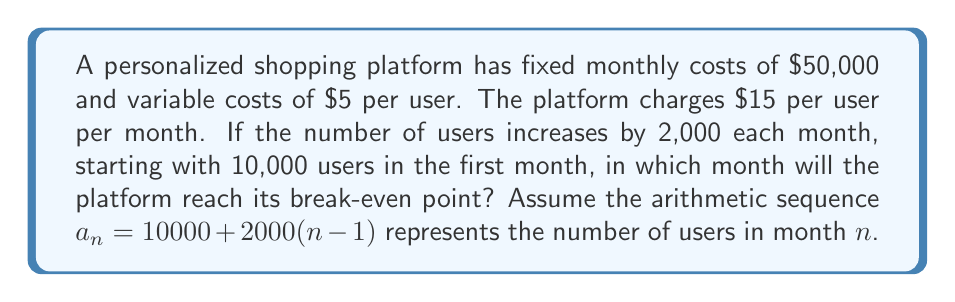Can you answer this question? Let's approach this step-by-step:

1) First, we need to set up the revenue and cost functions:
   Revenue: $R(n) = 15a_n$
   Costs: $C(n) = 50000 + 5a_n$

2) The break-even point occurs when revenue equals costs:
   $R(n) = C(n)$
   $15a_n = 50000 + 5a_n$

3) Substituting the arithmetic sequence for $a_n$:
   $15[10000 + 2000(n-1)] = 50000 + 5[10000 + 2000(n-1)]$

4) Simplify the left side:
   $150000 + 30000(n-1) = 50000 + 50000 + 10000(n-1)$

5) Simplify further:
   $150000 + 30000n - 30000 = 100000 + 10000n - 10000$

6) Combine like terms:
   $120000 + 30000n = 90000 + 10000n$

7) Subtract 90000 from both sides:
   $30000 + 30000n = 10000n$

8) Subtract 10000n from both sides:
   $30000 = -20000n$

9) Divide both sides by -20000:
   $-1.5 = n$

10) Since n represents months, we need to round up to the next whole number:
    $n = 2$

Therefore, the platform will reach its break-even point in the 2nd month.
Answer: 2nd month 